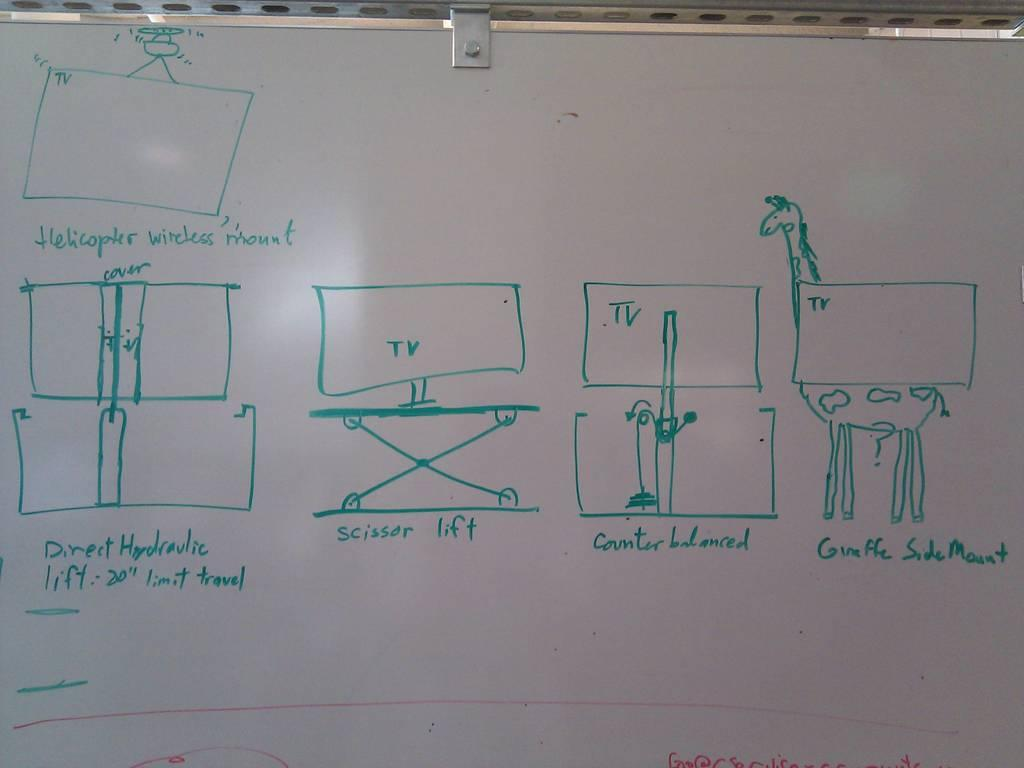<image>
Render a clear and concise summary of the photo. A whiteboard with pictures, several of which say TV. 